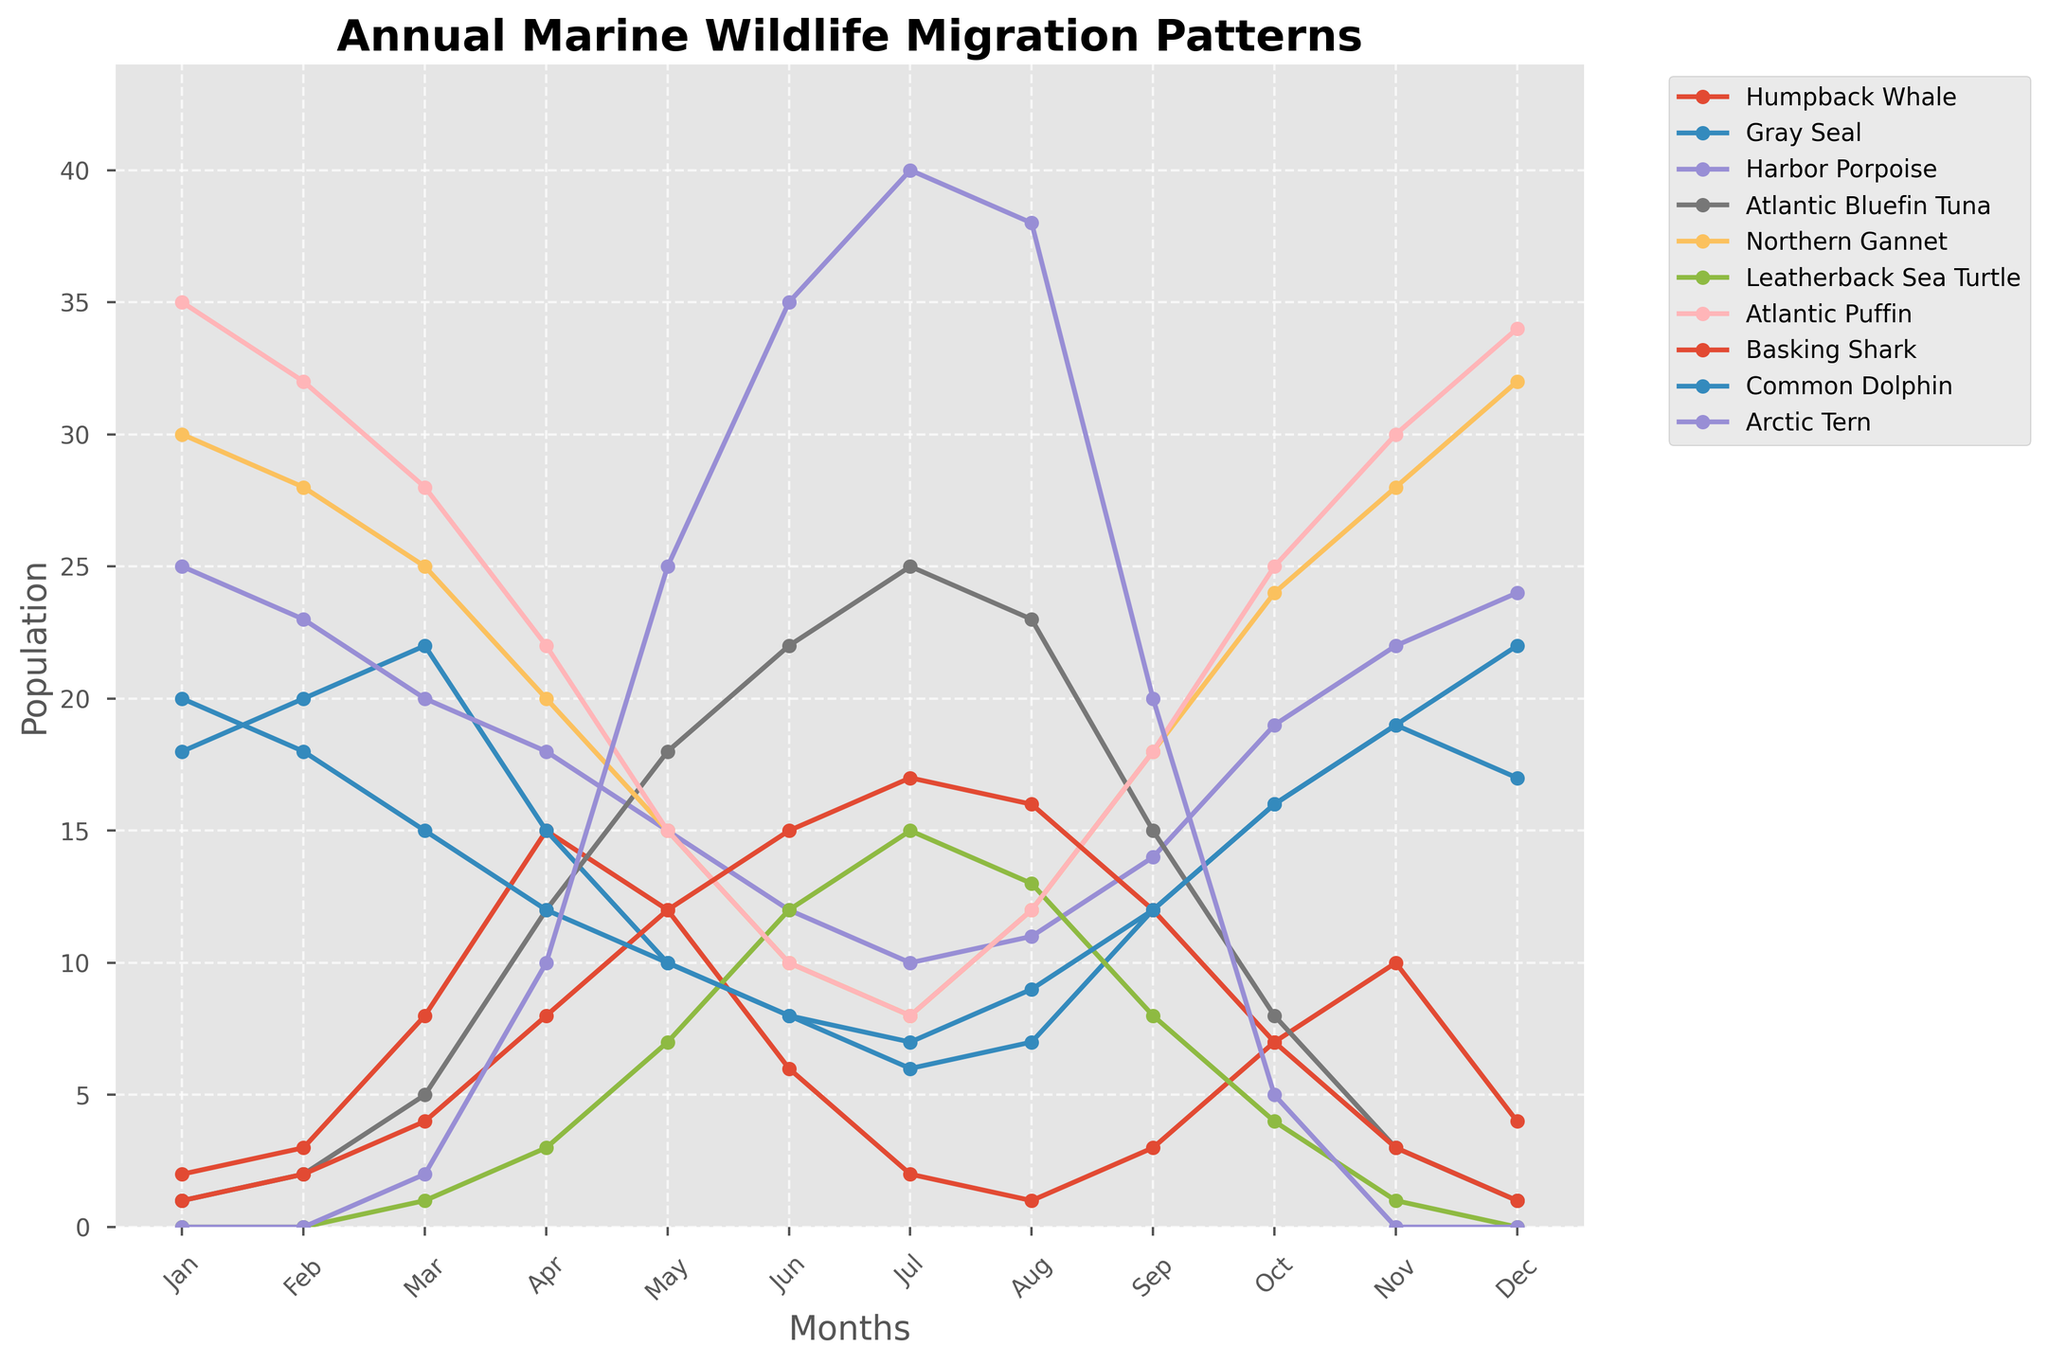Which species has the highest population in January? To find this, look at the population values on the y-axis for the different species in January and identify the highest one.
Answer: Atlantic Puffin Between Humpback Whale and Gray Seal, which species has a higher population in June? Compare the population values for Humpback Whale and Gray Seal in the month of June on the y-axis.
Answer: Gray Seal What is the average population of the Northern Gannet over the year? Sum the population values for Northern Gannet from January to December, then divide by 12 (the number of months): (30 + 28 + 25 + 20 + 15 + 10 + 8 + 12 + 18 + 24 + 28 + 32) / 12
Answer: 21 Which months have the highest population for Arctic Tern and what is that value? Look at the line for Arctic Tern and find the highest peak(s) on the y-axis and note the corresponding month(s).
Answer: June and July, value is 40 What is the difference in population between Atlantic Bluefin Tuna in May and December? Subtract the population value for December from the population value for May: 18 - 1
Answer: 17 Which species shows the most significant population increase from January to its peak month? Identify the highest increase by comparing the population differences from January to their respective peak months for each species.
Answer: Arctic Tern Are there any species with zero population in some months? If so, which one(s)? Look for lines that touch or start from the y-axis at a height of 0.
Answer: Leatherback Sea Turtle, Arctic Tern In which month does the population of Harbor Porpoise start to decline? Observe the trend of the Harbor Porpoise line and identify the month after which the population value decreases.
Answer: April Compare the population trend of Basking Shark and Common Dolphin. Which months have similar population values for both species? Look for months where the y-axis values for Basking Shark and Common Dolphin lines are close or similar.
Answer: July and August What is the total population of the Common Dolphin across all months? Sum the population values for Common Dolphin from January to December: 20 + 18 + 15 + 12 + 10 + 8 + 7 + 9 + 12 + 16 + 19 + 22
Answer: 168 